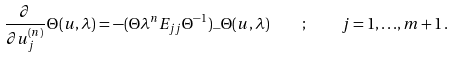Convert formula to latex. <formula><loc_0><loc_0><loc_500><loc_500>\frac { \partial } { \partial u _ { j } ^ { ( n ) } } \, \Theta ( { u } , \lambda ) = - ( \Theta \lambda ^ { n } E _ { j j } { \Theta } ^ { - 1 } ) _ { - } \Theta ( { u } , \lambda ) \quad ; \quad j = 1 , { \dots } , m + 1 \, .</formula> 